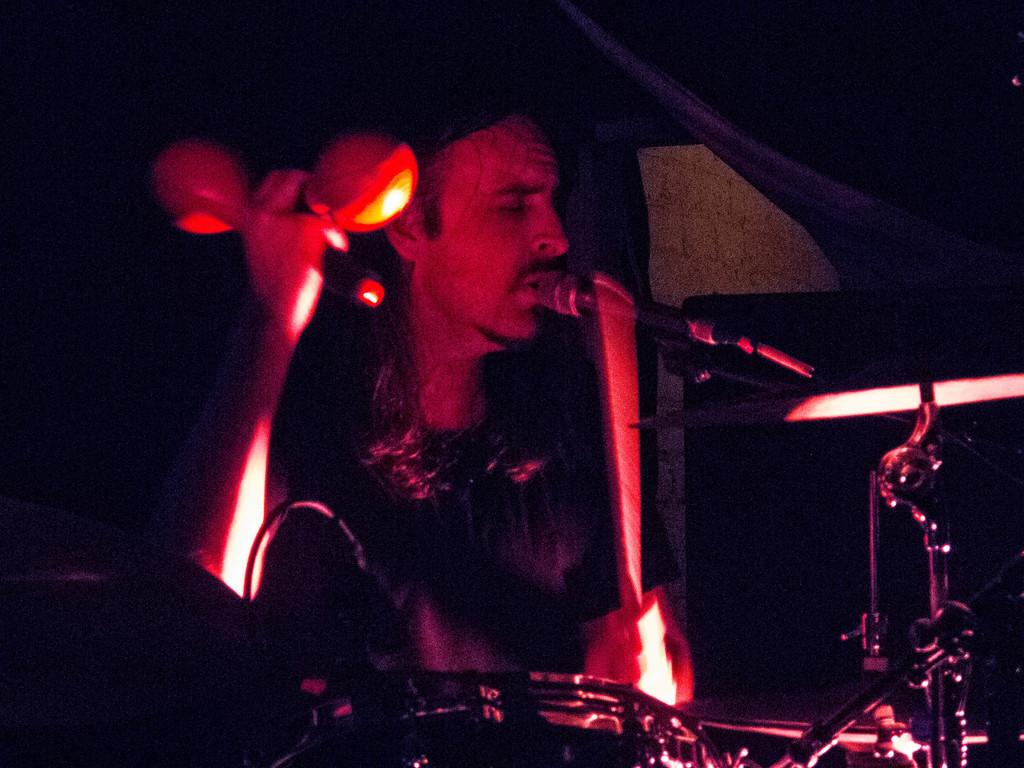What is the person in the image holding? The person is holding objects in the image. Can you identify any specific objects being held by the person? Yes, there is a mic in the image. What type of musical instrument is visible in the image? There are electronic drums in the image. What is the color of the background in the image? The background of the image is dark. What type of magic trick is the person performing with the scarf in the image? There is no scarf present in the image, and no magic trick is being performed. 